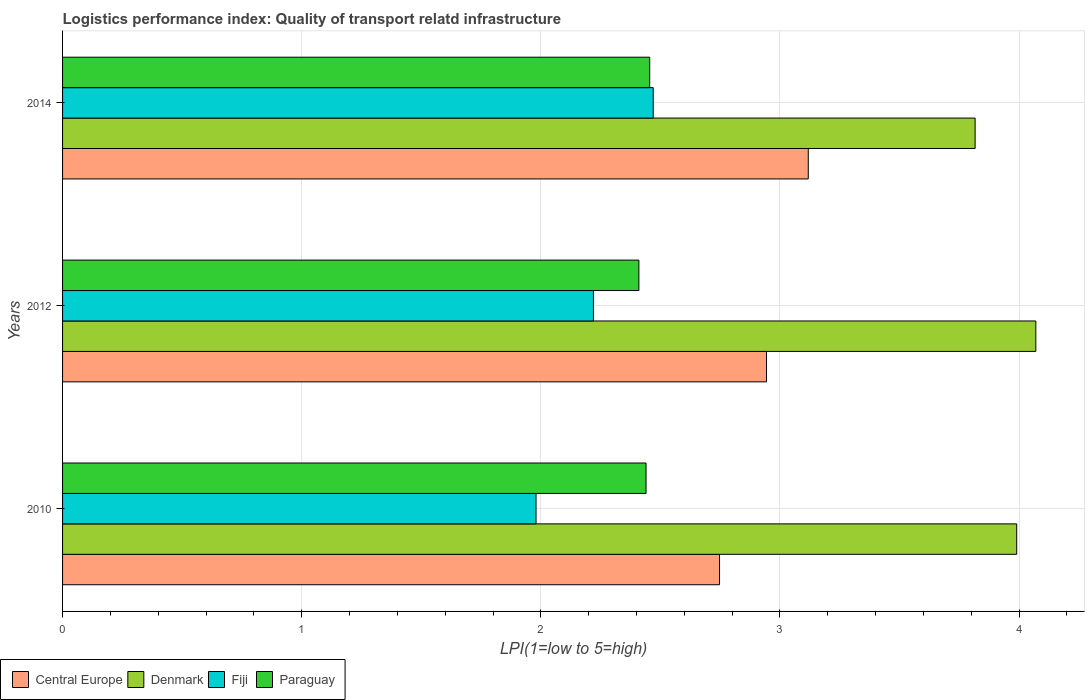How many different coloured bars are there?
Make the answer very short. 4. Are the number of bars on each tick of the Y-axis equal?
Your response must be concise. Yes. What is the logistics performance index in Central Europe in 2014?
Provide a short and direct response. 3.12. Across all years, what is the maximum logistics performance index in Paraguay?
Keep it short and to the point. 2.46. Across all years, what is the minimum logistics performance index in Denmark?
Keep it short and to the point. 3.82. In which year was the logistics performance index in Central Europe maximum?
Provide a short and direct response. 2014. In which year was the logistics performance index in Paraguay minimum?
Ensure brevity in your answer.  2012. What is the total logistics performance index in Central Europe in the graph?
Give a very brief answer. 8.81. What is the difference between the logistics performance index in Denmark in 2010 and that in 2012?
Your answer should be very brief. -0.08. What is the difference between the logistics performance index in Paraguay in 2014 and the logistics performance index in Denmark in 2012?
Offer a terse response. -1.61. What is the average logistics performance index in Fiji per year?
Your response must be concise. 2.22. In the year 2012, what is the difference between the logistics performance index in Paraguay and logistics performance index in Denmark?
Make the answer very short. -1.66. What is the ratio of the logistics performance index in Denmark in 2012 to that in 2014?
Offer a terse response. 1.07. What is the difference between the highest and the lowest logistics performance index in Paraguay?
Offer a very short reply. 0.05. What does the 3rd bar from the top in 2010 represents?
Your answer should be compact. Denmark. What does the 2nd bar from the bottom in 2014 represents?
Provide a succinct answer. Denmark. Is it the case that in every year, the sum of the logistics performance index in Paraguay and logistics performance index in Central Europe is greater than the logistics performance index in Denmark?
Your answer should be very brief. Yes. How many bars are there?
Provide a short and direct response. 12. Are all the bars in the graph horizontal?
Give a very brief answer. Yes. How many years are there in the graph?
Your answer should be very brief. 3. What is the difference between two consecutive major ticks on the X-axis?
Give a very brief answer. 1. Are the values on the major ticks of X-axis written in scientific E-notation?
Your answer should be compact. No. Does the graph contain any zero values?
Provide a short and direct response. No. Does the graph contain grids?
Provide a short and direct response. Yes. Where does the legend appear in the graph?
Make the answer very short. Bottom left. What is the title of the graph?
Offer a very short reply. Logistics performance index: Quality of transport relatd infrastructure. What is the label or title of the X-axis?
Your response must be concise. LPI(1=low to 5=high). What is the label or title of the Y-axis?
Your answer should be compact. Years. What is the LPI(1=low to 5=high) in Central Europe in 2010?
Make the answer very short. 2.75. What is the LPI(1=low to 5=high) in Denmark in 2010?
Provide a short and direct response. 3.99. What is the LPI(1=low to 5=high) in Fiji in 2010?
Keep it short and to the point. 1.98. What is the LPI(1=low to 5=high) in Paraguay in 2010?
Keep it short and to the point. 2.44. What is the LPI(1=low to 5=high) in Central Europe in 2012?
Offer a terse response. 2.94. What is the LPI(1=low to 5=high) in Denmark in 2012?
Provide a short and direct response. 4.07. What is the LPI(1=low to 5=high) of Fiji in 2012?
Make the answer very short. 2.22. What is the LPI(1=low to 5=high) in Paraguay in 2012?
Keep it short and to the point. 2.41. What is the LPI(1=low to 5=high) of Central Europe in 2014?
Ensure brevity in your answer.  3.12. What is the LPI(1=low to 5=high) in Denmark in 2014?
Offer a very short reply. 3.82. What is the LPI(1=low to 5=high) in Fiji in 2014?
Ensure brevity in your answer.  2.47. What is the LPI(1=low to 5=high) of Paraguay in 2014?
Your answer should be very brief. 2.46. Across all years, what is the maximum LPI(1=low to 5=high) of Central Europe?
Provide a succinct answer. 3.12. Across all years, what is the maximum LPI(1=low to 5=high) in Denmark?
Offer a very short reply. 4.07. Across all years, what is the maximum LPI(1=low to 5=high) in Fiji?
Provide a short and direct response. 2.47. Across all years, what is the maximum LPI(1=low to 5=high) of Paraguay?
Give a very brief answer. 2.46. Across all years, what is the minimum LPI(1=low to 5=high) of Central Europe?
Give a very brief answer. 2.75. Across all years, what is the minimum LPI(1=low to 5=high) in Denmark?
Offer a terse response. 3.82. Across all years, what is the minimum LPI(1=low to 5=high) in Fiji?
Your answer should be compact. 1.98. Across all years, what is the minimum LPI(1=low to 5=high) in Paraguay?
Give a very brief answer. 2.41. What is the total LPI(1=low to 5=high) in Central Europe in the graph?
Ensure brevity in your answer.  8.81. What is the total LPI(1=low to 5=high) of Denmark in the graph?
Give a very brief answer. 11.88. What is the total LPI(1=low to 5=high) in Fiji in the graph?
Your answer should be compact. 6.67. What is the total LPI(1=low to 5=high) of Paraguay in the graph?
Ensure brevity in your answer.  7.31. What is the difference between the LPI(1=low to 5=high) of Central Europe in 2010 and that in 2012?
Your response must be concise. -0.2. What is the difference between the LPI(1=low to 5=high) of Denmark in 2010 and that in 2012?
Ensure brevity in your answer.  -0.08. What is the difference between the LPI(1=low to 5=high) of Fiji in 2010 and that in 2012?
Offer a very short reply. -0.24. What is the difference between the LPI(1=low to 5=high) in Central Europe in 2010 and that in 2014?
Your answer should be very brief. -0.37. What is the difference between the LPI(1=low to 5=high) of Denmark in 2010 and that in 2014?
Give a very brief answer. 0.17. What is the difference between the LPI(1=low to 5=high) in Fiji in 2010 and that in 2014?
Provide a succinct answer. -0.49. What is the difference between the LPI(1=low to 5=high) in Paraguay in 2010 and that in 2014?
Provide a succinct answer. -0.02. What is the difference between the LPI(1=low to 5=high) in Central Europe in 2012 and that in 2014?
Your answer should be compact. -0.17. What is the difference between the LPI(1=low to 5=high) in Denmark in 2012 and that in 2014?
Give a very brief answer. 0.25. What is the difference between the LPI(1=low to 5=high) in Fiji in 2012 and that in 2014?
Your answer should be compact. -0.25. What is the difference between the LPI(1=low to 5=high) of Paraguay in 2012 and that in 2014?
Give a very brief answer. -0.05. What is the difference between the LPI(1=low to 5=high) in Central Europe in 2010 and the LPI(1=low to 5=high) in Denmark in 2012?
Your answer should be very brief. -1.32. What is the difference between the LPI(1=low to 5=high) in Central Europe in 2010 and the LPI(1=low to 5=high) in Fiji in 2012?
Make the answer very short. 0.53. What is the difference between the LPI(1=low to 5=high) of Central Europe in 2010 and the LPI(1=low to 5=high) of Paraguay in 2012?
Make the answer very short. 0.34. What is the difference between the LPI(1=low to 5=high) in Denmark in 2010 and the LPI(1=low to 5=high) in Fiji in 2012?
Ensure brevity in your answer.  1.77. What is the difference between the LPI(1=low to 5=high) of Denmark in 2010 and the LPI(1=low to 5=high) of Paraguay in 2012?
Keep it short and to the point. 1.58. What is the difference between the LPI(1=low to 5=high) of Fiji in 2010 and the LPI(1=low to 5=high) of Paraguay in 2012?
Your answer should be very brief. -0.43. What is the difference between the LPI(1=low to 5=high) in Central Europe in 2010 and the LPI(1=low to 5=high) in Denmark in 2014?
Offer a terse response. -1.07. What is the difference between the LPI(1=low to 5=high) in Central Europe in 2010 and the LPI(1=low to 5=high) in Fiji in 2014?
Ensure brevity in your answer.  0.28. What is the difference between the LPI(1=low to 5=high) in Central Europe in 2010 and the LPI(1=low to 5=high) in Paraguay in 2014?
Your answer should be compact. 0.29. What is the difference between the LPI(1=low to 5=high) of Denmark in 2010 and the LPI(1=low to 5=high) of Fiji in 2014?
Make the answer very short. 1.52. What is the difference between the LPI(1=low to 5=high) in Denmark in 2010 and the LPI(1=low to 5=high) in Paraguay in 2014?
Make the answer very short. 1.53. What is the difference between the LPI(1=low to 5=high) of Fiji in 2010 and the LPI(1=low to 5=high) of Paraguay in 2014?
Keep it short and to the point. -0.48. What is the difference between the LPI(1=low to 5=high) in Central Europe in 2012 and the LPI(1=low to 5=high) in Denmark in 2014?
Your answer should be very brief. -0.87. What is the difference between the LPI(1=low to 5=high) in Central Europe in 2012 and the LPI(1=low to 5=high) in Fiji in 2014?
Your answer should be very brief. 0.47. What is the difference between the LPI(1=low to 5=high) in Central Europe in 2012 and the LPI(1=low to 5=high) in Paraguay in 2014?
Your answer should be very brief. 0.49. What is the difference between the LPI(1=low to 5=high) of Denmark in 2012 and the LPI(1=low to 5=high) of Paraguay in 2014?
Offer a very short reply. 1.61. What is the difference between the LPI(1=low to 5=high) of Fiji in 2012 and the LPI(1=low to 5=high) of Paraguay in 2014?
Offer a very short reply. -0.24. What is the average LPI(1=low to 5=high) in Central Europe per year?
Your response must be concise. 2.94. What is the average LPI(1=low to 5=high) of Denmark per year?
Your response must be concise. 3.96. What is the average LPI(1=low to 5=high) in Fiji per year?
Provide a short and direct response. 2.22. What is the average LPI(1=low to 5=high) of Paraguay per year?
Make the answer very short. 2.44. In the year 2010, what is the difference between the LPI(1=low to 5=high) in Central Europe and LPI(1=low to 5=high) in Denmark?
Your answer should be compact. -1.24. In the year 2010, what is the difference between the LPI(1=low to 5=high) of Central Europe and LPI(1=low to 5=high) of Fiji?
Offer a very short reply. 0.77. In the year 2010, what is the difference between the LPI(1=low to 5=high) of Central Europe and LPI(1=low to 5=high) of Paraguay?
Ensure brevity in your answer.  0.31. In the year 2010, what is the difference between the LPI(1=low to 5=high) of Denmark and LPI(1=low to 5=high) of Fiji?
Give a very brief answer. 2.01. In the year 2010, what is the difference between the LPI(1=low to 5=high) in Denmark and LPI(1=low to 5=high) in Paraguay?
Keep it short and to the point. 1.55. In the year 2010, what is the difference between the LPI(1=low to 5=high) of Fiji and LPI(1=low to 5=high) of Paraguay?
Make the answer very short. -0.46. In the year 2012, what is the difference between the LPI(1=low to 5=high) of Central Europe and LPI(1=low to 5=high) of Denmark?
Your answer should be very brief. -1.13. In the year 2012, what is the difference between the LPI(1=low to 5=high) of Central Europe and LPI(1=low to 5=high) of Fiji?
Keep it short and to the point. 0.72. In the year 2012, what is the difference between the LPI(1=low to 5=high) in Central Europe and LPI(1=low to 5=high) in Paraguay?
Give a very brief answer. 0.53. In the year 2012, what is the difference between the LPI(1=low to 5=high) of Denmark and LPI(1=low to 5=high) of Fiji?
Offer a very short reply. 1.85. In the year 2012, what is the difference between the LPI(1=low to 5=high) of Denmark and LPI(1=low to 5=high) of Paraguay?
Your answer should be compact. 1.66. In the year 2012, what is the difference between the LPI(1=low to 5=high) in Fiji and LPI(1=low to 5=high) in Paraguay?
Keep it short and to the point. -0.19. In the year 2014, what is the difference between the LPI(1=low to 5=high) in Central Europe and LPI(1=low to 5=high) in Denmark?
Provide a succinct answer. -0.7. In the year 2014, what is the difference between the LPI(1=low to 5=high) of Central Europe and LPI(1=low to 5=high) of Fiji?
Offer a very short reply. 0.65. In the year 2014, what is the difference between the LPI(1=low to 5=high) of Central Europe and LPI(1=low to 5=high) of Paraguay?
Your answer should be compact. 0.66. In the year 2014, what is the difference between the LPI(1=low to 5=high) in Denmark and LPI(1=low to 5=high) in Fiji?
Make the answer very short. 1.35. In the year 2014, what is the difference between the LPI(1=low to 5=high) of Denmark and LPI(1=low to 5=high) of Paraguay?
Provide a succinct answer. 1.36. In the year 2014, what is the difference between the LPI(1=low to 5=high) of Fiji and LPI(1=low to 5=high) of Paraguay?
Your answer should be compact. 0.01. What is the ratio of the LPI(1=low to 5=high) in Central Europe in 2010 to that in 2012?
Your response must be concise. 0.93. What is the ratio of the LPI(1=low to 5=high) in Denmark in 2010 to that in 2012?
Make the answer very short. 0.98. What is the ratio of the LPI(1=low to 5=high) of Fiji in 2010 to that in 2012?
Your response must be concise. 0.89. What is the ratio of the LPI(1=low to 5=high) of Paraguay in 2010 to that in 2012?
Keep it short and to the point. 1.01. What is the ratio of the LPI(1=low to 5=high) in Central Europe in 2010 to that in 2014?
Ensure brevity in your answer.  0.88. What is the ratio of the LPI(1=low to 5=high) of Denmark in 2010 to that in 2014?
Give a very brief answer. 1.05. What is the ratio of the LPI(1=low to 5=high) in Fiji in 2010 to that in 2014?
Your response must be concise. 0.8. What is the ratio of the LPI(1=low to 5=high) of Central Europe in 2012 to that in 2014?
Your answer should be very brief. 0.94. What is the ratio of the LPI(1=low to 5=high) of Denmark in 2012 to that in 2014?
Your answer should be compact. 1.07. What is the ratio of the LPI(1=low to 5=high) of Fiji in 2012 to that in 2014?
Ensure brevity in your answer.  0.9. What is the ratio of the LPI(1=low to 5=high) in Paraguay in 2012 to that in 2014?
Make the answer very short. 0.98. What is the difference between the highest and the second highest LPI(1=low to 5=high) in Central Europe?
Ensure brevity in your answer.  0.17. What is the difference between the highest and the second highest LPI(1=low to 5=high) in Paraguay?
Ensure brevity in your answer.  0.02. What is the difference between the highest and the lowest LPI(1=low to 5=high) in Central Europe?
Your response must be concise. 0.37. What is the difference between the highest and the lowest LPI(1=low to 5=high) in Denmark?
Provide a succinct answer. 0.25. What is the difference between the highest and the lowest LPI(1=low to 5=high) in Fiji?
Ensure brevity in your answer.  0.49. What is the difference between the highest and the lowest LPI(1=low to 5=high) of Paraguay?
Keep it short and to the point. 0.05. 